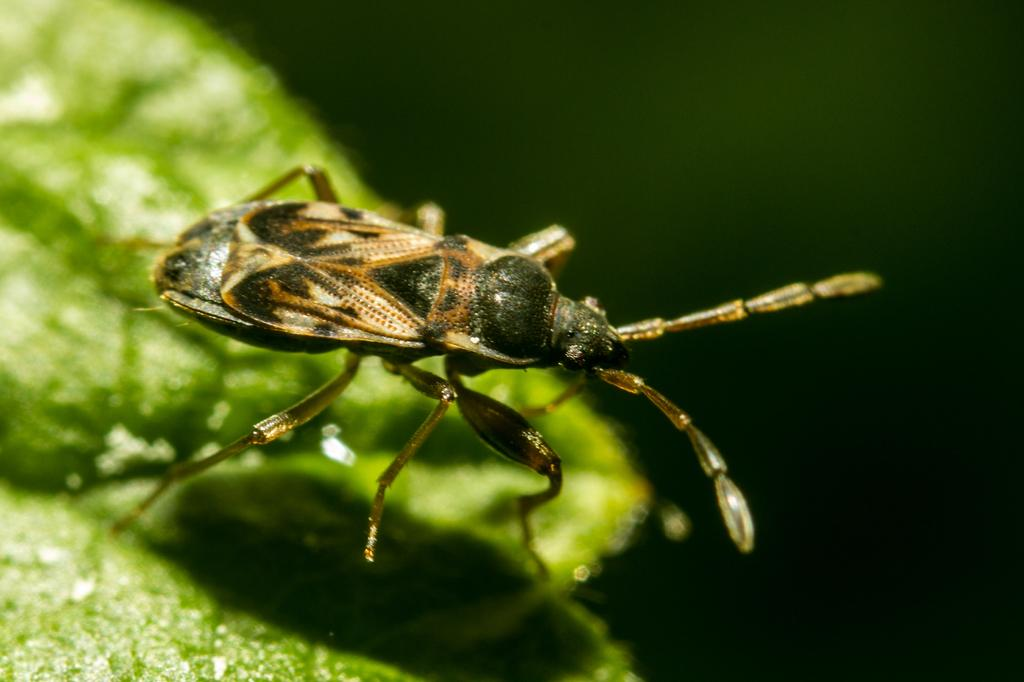What is present on the leaf in the image? There is an insect on a leaf in the image. Can you describe the background of the image? The background of the image is blurred. What type of hair can be seen on the woman in the image? There is no woman present in the image, only an insect on a leaf. What kind of paste is being used by the insect in the image? There is no paste present in the image; it features an insect on a leaf. 